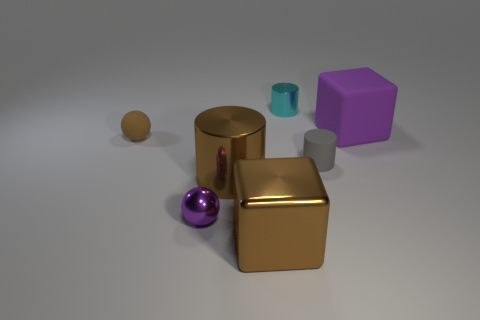Add 1 blocks. How many objects exist? 8 Subtract all cylinders. How many objects are left? 4 Add 2 brown spheres. How many brown spheres exist? 3 Subtract 0 purple cylinders. How many objects are left? 7 Subtract all tiny brown balls. Subtract all tiny red cylinders. How many objects are left? 6 Add 7 purple things. How many purple things are left? 9 